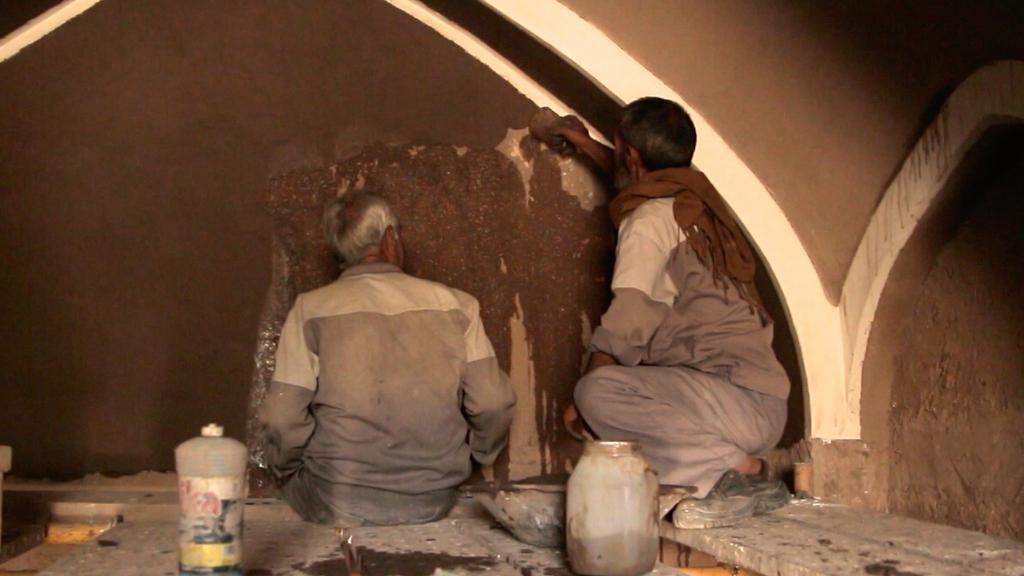Describe this image in one or two sentences. In this image we can see there are two people sitting on the floor and holding an object in their hands and painting the wall. In the backside of them there are two bottles on the ground. In the background of the image there is a wall. 